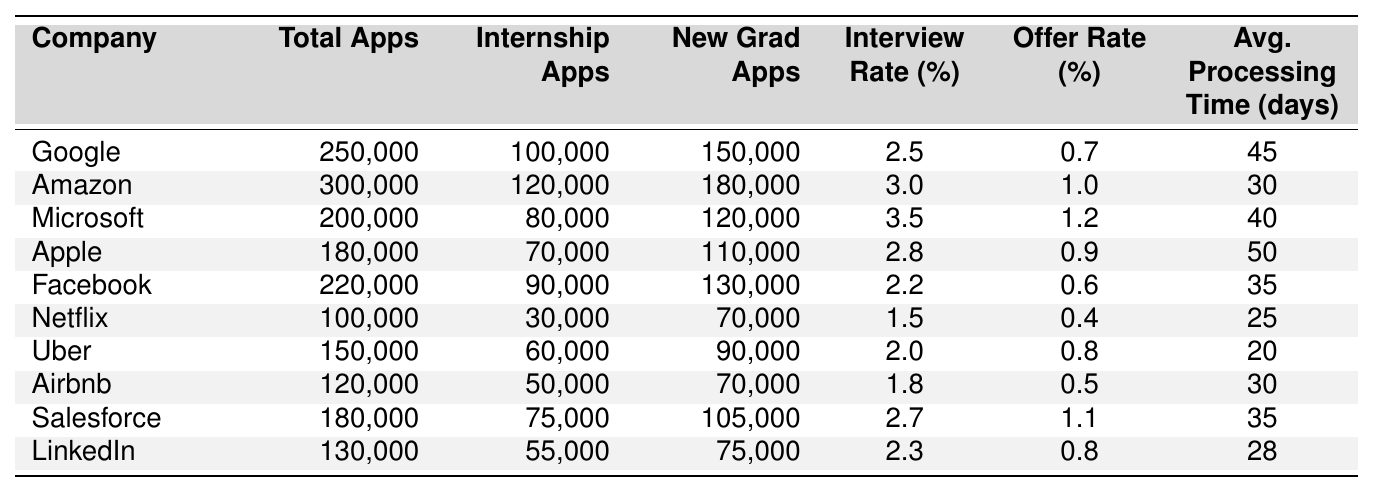What is the company with the highest total applications? By examining the "Total Applications" column, Amazon has the highest total with 300,000 applications.
Answer: Amazon What is the interview rate for Microsoft? The "Interview Rate (%)" for Microsoft is 3.5%, as indicated in the table.
Answer: 3.5% Which company has the lowest offer rate? Looking at the "Offer Rate (%)" column, Netflix has the lowest rate at 0.4%.
Answer: Netflix What is the average application processing time for Apple and Google combined? The processing times for Apple (50 days) and Google (45 days) sum to 95 days. Dividing by 2 gives an average of 47.5 days.
Answer: 47.5 Is the interview rate for Facebook higher than the offer rate for Amazon? Facebook's interview rate is 2.2%, while Amazon's offer rate is 1.0%. Since 2.2% is greater than 1.0%, the statement is true.
Answer: Yes What is the total number of internship applications across all companies? Summing the "Internship Applications" column gives a total of 100,000 + 120,000 + 80,000 + 70,000 + 90,000 + 30,000 + 60,000 + 50,000 + 75,000 + 55,000 = 830,000.
Answer: 830,000 Which company has the highest interview rate and what is it? Microsoft has the highest interview rate of 3.5% as shown in the "Interview Rate (%)" column.
Answer: Microsoft, 3.5% How does the average offer rate compare to the average interview rate across all companies? The average offer rate is calculated as (0.7 + 1.0 + 1.2 + 0.9 + 0.6 + 0.4 + 0.8 + 0.5 + 1.1 + 0.8) / 10 = 0.66%, while the average interview rate is (2.5 + 3.0 + 3.5 + 2.8 + 2.2 + 1.5 + 2.0 + 1.8 + 2.7 + 2.3) / 10 = 2.36%. So, 2.36% is significantly higher than 0.66%.
Answer: Average interview rate is higher What percentage of applications at Netflix resulted in an offer? To find this, divide the offer rate (0.4%) by the total applications (100,000) and multiply by 100. Thus, 0.4% of 100,000 = 400 offers.
Answer: 400 offers Which company has the lowest average application processing time and what is it? By checking the "Average Application Processing Time (days)", Uber has the lowest processing time at 20 days.
Answer: Uber, 20 days 